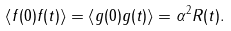<formula> <loc_0><loc_0><loc_500><loc_500>\left < f ( 0 ) f ( t ) \right > = \left < g ( 0 ) g ( t ) \right > = \alpha ^ { 2 } R ( t ) .</formula> 